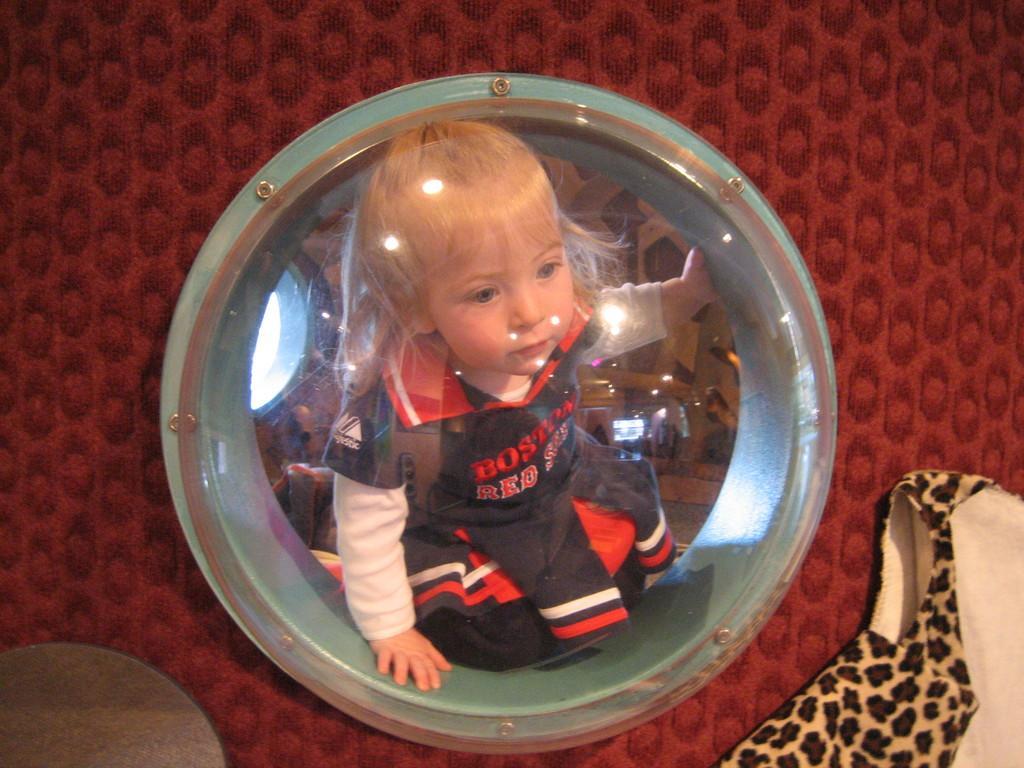Please provide a concise description of this image. In this picture there is a girl behind the glass and there are objects and there is a window behind the glass. At the bottom right there is a cloth. At the bottom left there is a wooden object. At the back there is a red color cloth. 